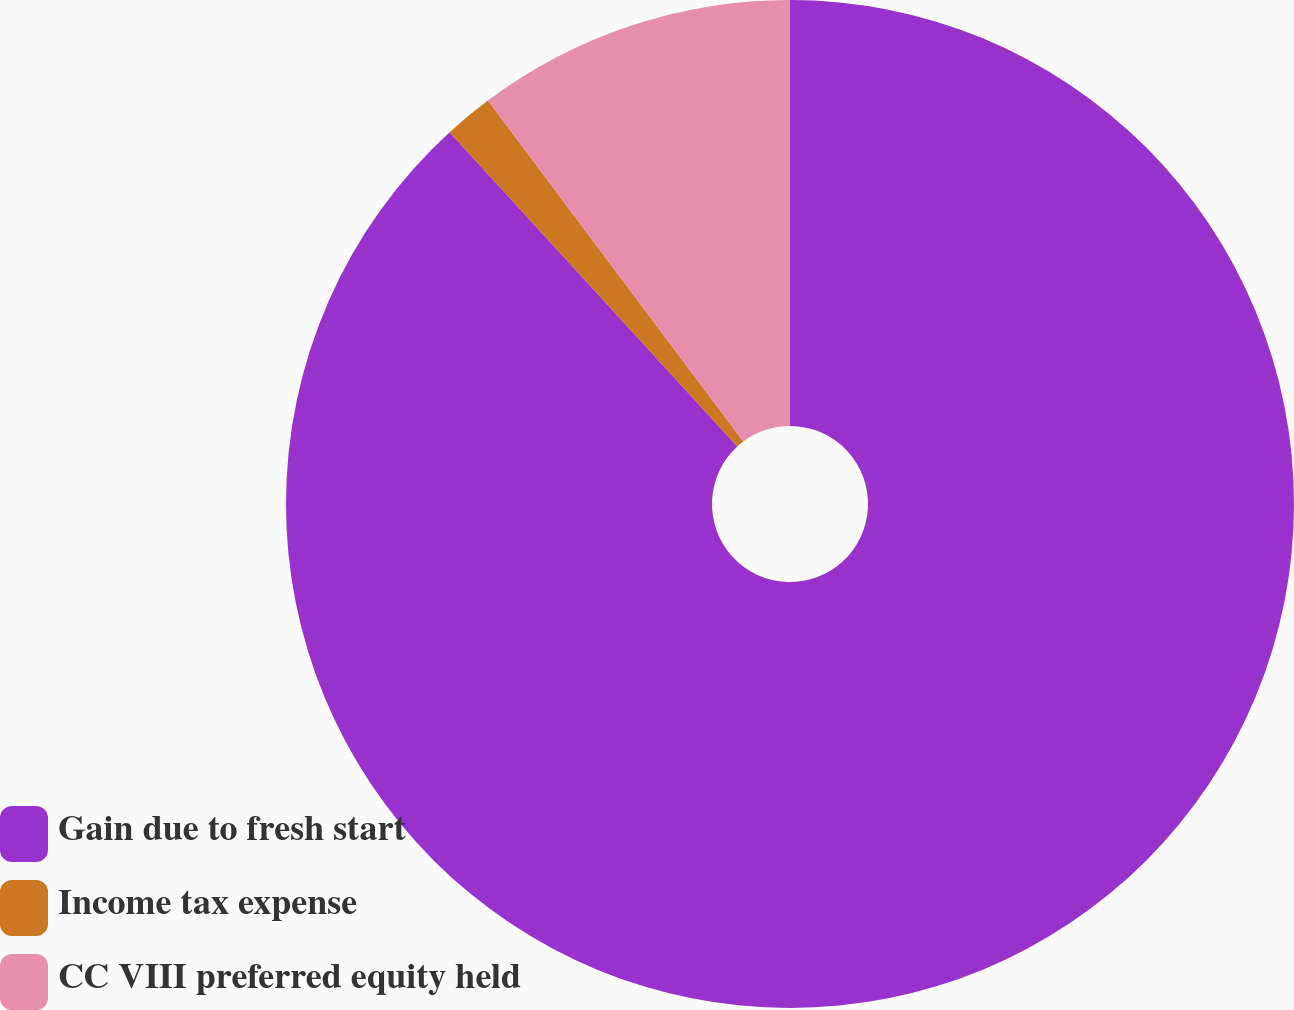Convert chart to OTSL. <chart><loc_0><loc_0><loc_500><loc_500><pie_chart><fcel>Gain due to fresh start<fcel>Income tax expense<fcel>CC VIII preferred equity held<nl><fcel>88.2%<fcel>1.57%<fcel>10.23%<nl></chart> 